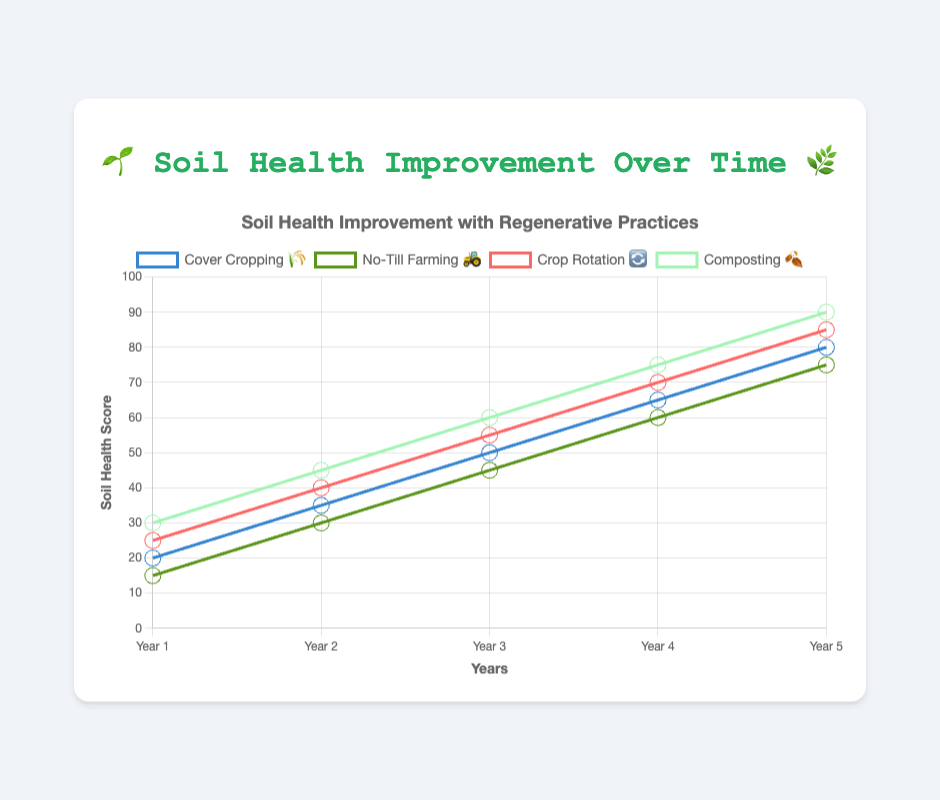How many years of data are displayed? The x-axis labels from Year 1 to Year 5 indicate the number of years of data.
Answer: 5 years Which regenerative practice shows the highest soil health improvement in Year 5? At Year 5, the data points show Composting 🍂 with the highest soil health score of 90.
Answer: Composting 🍂 What is the average soil health score for Cover Cropping 🌾 over the 5 years? The soil health scores for Cover Cropping 🌾 are [20, 35, 50, 65, 80]. Adding these up gives 250, and dividing by 5 years results in an average of 50.
Answer: 50 How much did the soil health score increase from Year 1 to Year 3 for No-Till Farming 🚜? The soil health score for No-Till Farming 🚜 was 15 in Year 1 and 45 in Year 3. The increase is 45 - 15 = 30.
Answer: 30 Which practice showed the least improvement in soil health from Year 1 to Year 5? From the starting point to Year 5, No-Till Farming 🚜 has the smallest increase, going from 15 to 75.
Answer: No-Till Farming 🚜 In Year 4, which practice has the second-highest soil health score? In Year 4, the soil health scores are:
- Cover Cropping 🌾: 65
- No-Till Farming 🚜: 60
- Crop Rotation 🔄: 70
- Composting 🍂: 75
The second-highest score is 70, which is for Crop Rotation 🔄.
Answer: Crop Rotation 🔄 How many practices have achieved a soil health score of 60 or more by Year 3? By Year 3, the data indicates the following scores: 
- Cover Cropping 🌾: 50
- No-Till Farming 🚜: 45
- Crop Rotation 🔄: 55
- Composting 🍂: 60
Only Composting 🍂 achieves a score of 60 or more.
Answer: 1 practice Which two practices are closest in soil health score in Year 2? In Year 2, the scores are: 
- Cover Cropping 🌾: 35
- No-Till Farming 🚜: 30
- Crop Rotation 🔄: 40
- Composting 🍂: 45
The closest scores are Cover Cropping 🌾 and No-Till Farming 🚜, with a difference of 35 - 30 = 5.
Answer: Cover Cropping 🌾 and No-Till Farming 🚜 What is the total sum of soil health scores for all practices in Year 5? In Year 5, the soil health scores are: 
- Cover Cropping 🌾: 80
- No-Till Farming 🚜: 75
- Crop Rotation 🔄: 85
- Composting 🍂: 90
Adding these scores gives 80 + 75 + 85 + 90 = 330.
Answer: 330 Considering the overall trend, which practice has shown the most consistent improvement in soil health? By examining the scores over 5 years, all practices show steady improvement, but Crop Rotation 🔄 consistently increases by 15 each year (25, 40, 55, 70, 85).
Answer: Crop Rotation 🔄 